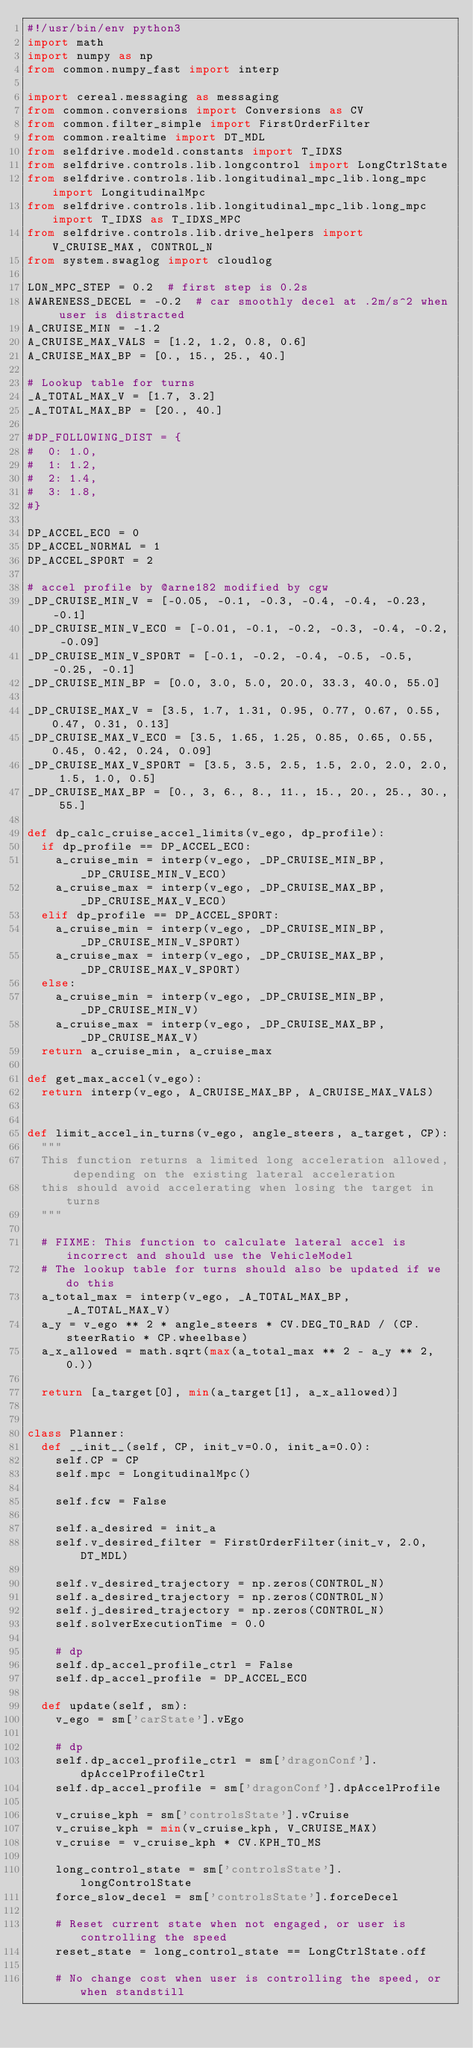Convert code to text. <code><loc_0><loc_0><loc_500><loc_500><_Python_>#!/usr/bin/env python3
import math
import numpy as np
from common.numpy_fast import interp

import cereal.messaging as messaging
from common.conversions import Conversions as CV
from common.filter_simple import FirstOrderFilter
from common.realtime import DT_MDL
from selfdrive.modeld.constants import T_IDXS
from selfdrive.controls.lib.longcontrol import LongCtrlState
from selfdrive.controls.lib.longitudinal_mpc_lib.long_mpc import LongitudinalMpc
from selfdrive.controls.lib.longitudinal_mpc_lib.long_mpc import T_IDXS as T_IDXS_MPC
from selfdrive.controls.lib.drive_helpers import V_CRUISE_MAX, CONTROL_N
from system.swaglog import cloudlog

LON_MPC_STEP = 0.2  # first step is 0.2s
AWARENESS_DECEL = -0.2  # car smoothly decel at .2m/s^2 when user is distracted
A_CRUISE_MIN = -1.2
A_CRUISE_MAX_VALS = [1.2, 1.2, 0.8, 0.6]
A_CRUISE_MAX_BP = [0., 15., 25., 40.]

# Lookup table for turns
_A_TOTAL_MAX_V = [1.7, 3.2]
_A_TOTAL_MAX_BP = [20., 40.]

#DP_FOLLOWING_DIST = {
#  0: 1.0,
#  1: 1.2,
#  2: 1.4,
#  3: 1.8,
#}

DP_ACCEL_ECO = 0
DP_ACCEL_NORMAL = 1
DP_ACCEL_SPORT = 2

# accel profile by @arne182 modified by cgw
_DP_CRUISE_MIN_V = [-0.05, -0.1, -0.3, -0.4, -0.4, -0.23, -0.1]
_DP_CRUISE_MIN_V_ECO = [-0.01, -0.1, -0.2, -0.3, -0.4, -0.2, -0.09]
_DP_CRUISE_MIN_V_SPORT = [-0.1, -0.2, -0.4, -0.5, -0.5, -0.25, -0.1]
_DP_CRUISE_MIN_BP = [0.0, 3.0, 5.0, 20.0, 33.3, 40.0, 55.0]

_DP_CRUISE_MAX_V = [3.5, 1.7, 1.31, 0.95, 0.77, 0.67, 0.55, 0.47, 0.31, 0.13]
_DP_CRUISE_MAX_V_ECO = [3.5, 1.65, 1.25, 0.85, 0.65, 0.55, 0.45, 0.42, 0.24, 0.09]
_DP_CRUISE_MAX_V_SPORT = [3.5, 3.5, 2.5, 1.5, 2.0, 2.0, 2.0, 1.5, 1.0, 0.5]
_DP_CRUISE_MAX_BP = [0., 3, 6., 8., 11., 15., 20., 25., 30., 55.]

def dp_calc_cruise_accel_limits(v_ego, dp_profile):
  if dp_profile == DP_ACCEL_ECO:
    a_cruise_min = interp(v_ego, _DP_CRUISE_MIN_BP, _DP_CRUISE_MIN_V_ECO)
    a_cruise_max = interp(v_ego, _DP_CRUISE_MAX_BP, _DP_CRUISE_MAX_V_ECO)
  elif dp_profile == DP_ACCEL_SPORT:
    a_cruise_min = interp(v_ego, _DP_CRUISE_MIN_BP, _DP_CRUISE_MIN_V_SPORT)
    a_cruise_max = interp(v_ego, _DP_CRUISE_MAX_BP, _DP_CRUISE_MAX_V_SPORT)
  else:
    a_cruise_min = interp(v_ego, _DP_CRUISE_MIN_BP, _DP_CRUISE_MIN_V)
    a_cruise_max = interp(v_ego, _DP_CRUISE_MAX_BP, _DP_CRUISE_MAX_V)
  return a_cruise_min, a_cruise_max

def get_max_accel(v_ego):
  return interp(v_ego, A_CRUISE_MAX_BP, A_CRUISE_MAX_VALS)


def limit_accel_in_turns(v_ego, angle_steers, a_target, CP):
  """
  This function returns a limited long acceleration allowed, depending on the existing lateral acceleration
  this should avoid accelerating when losing the target in turns
  """

  # FIXME: This function to calculate lateral accel is incorrect and should use the VehicleModel
  # The lookup table for turns should also be updated if we do this
  a_total_max = interp(v_ego, _A_TOTAL_MAX_BP, _A_TOTAL_MAX_V)
  a_y = v_ego ** 2 * angle_steers * CV.DEG_TO_RAD / (CP.steerRatio * CP.wheelbase)
  a_x_allowed = math.sqrt(max(a_total_max ** 2 - a_y ** 2, 0.))

  return [a_target[0], min(a_target[1], a_x_allowed)]


class Planner:
  def __init__(self, CP, init_v=0.0, init_a=0.0):
    self.CP = CP
    self.mpc = LongitudinalMpc()

    self.fcw = False

    self.a_desired = init_a
    self.v_desired_filter = FirstOrderFilter(init_v, 2.0, DT_MDL)

    self.v_desired_trajectory = np.zeros(CONTROL_N)
    self.a_desired_trajectory = np.zeros(CONTROL_N)
    self.j_desired_trajectory = np.zeros(CONTROL_N)
    self.solverExecutionTime = 0.0

    # dp
    self.dp_accel_profile_ctrl = False
    self.dp_accel_profile = DP_ACCEL_ECO

  def update(self, sm):
    v_ego = sm['carState'].vEgo

    # dp
    self.dp_accel_profile_ctrl = sm['dragonConf'].dpAccelProfileCtrl
    self.dp_accel_profile = sm['dragonConf'].dpAccelProfile

    v_cruise_kph = sm['controlsState'].vCruise
    v_cruise_kph = min(v_cruise_kph, V_CRUISE_MAX)
    v_cruise = v_cruise_kph * CV.KPH_TO_MS

    long_control_state = sm['controlsState'].longControlState
    force_slow_decel = sm['controlsState'].forceDecel

    # Reset current state when not engaged, or user is controlling the speed
    reset_state = long_control_state == LongCtrlState.off

    # No change cost when user is controlling the speed, or when standstill</code> 